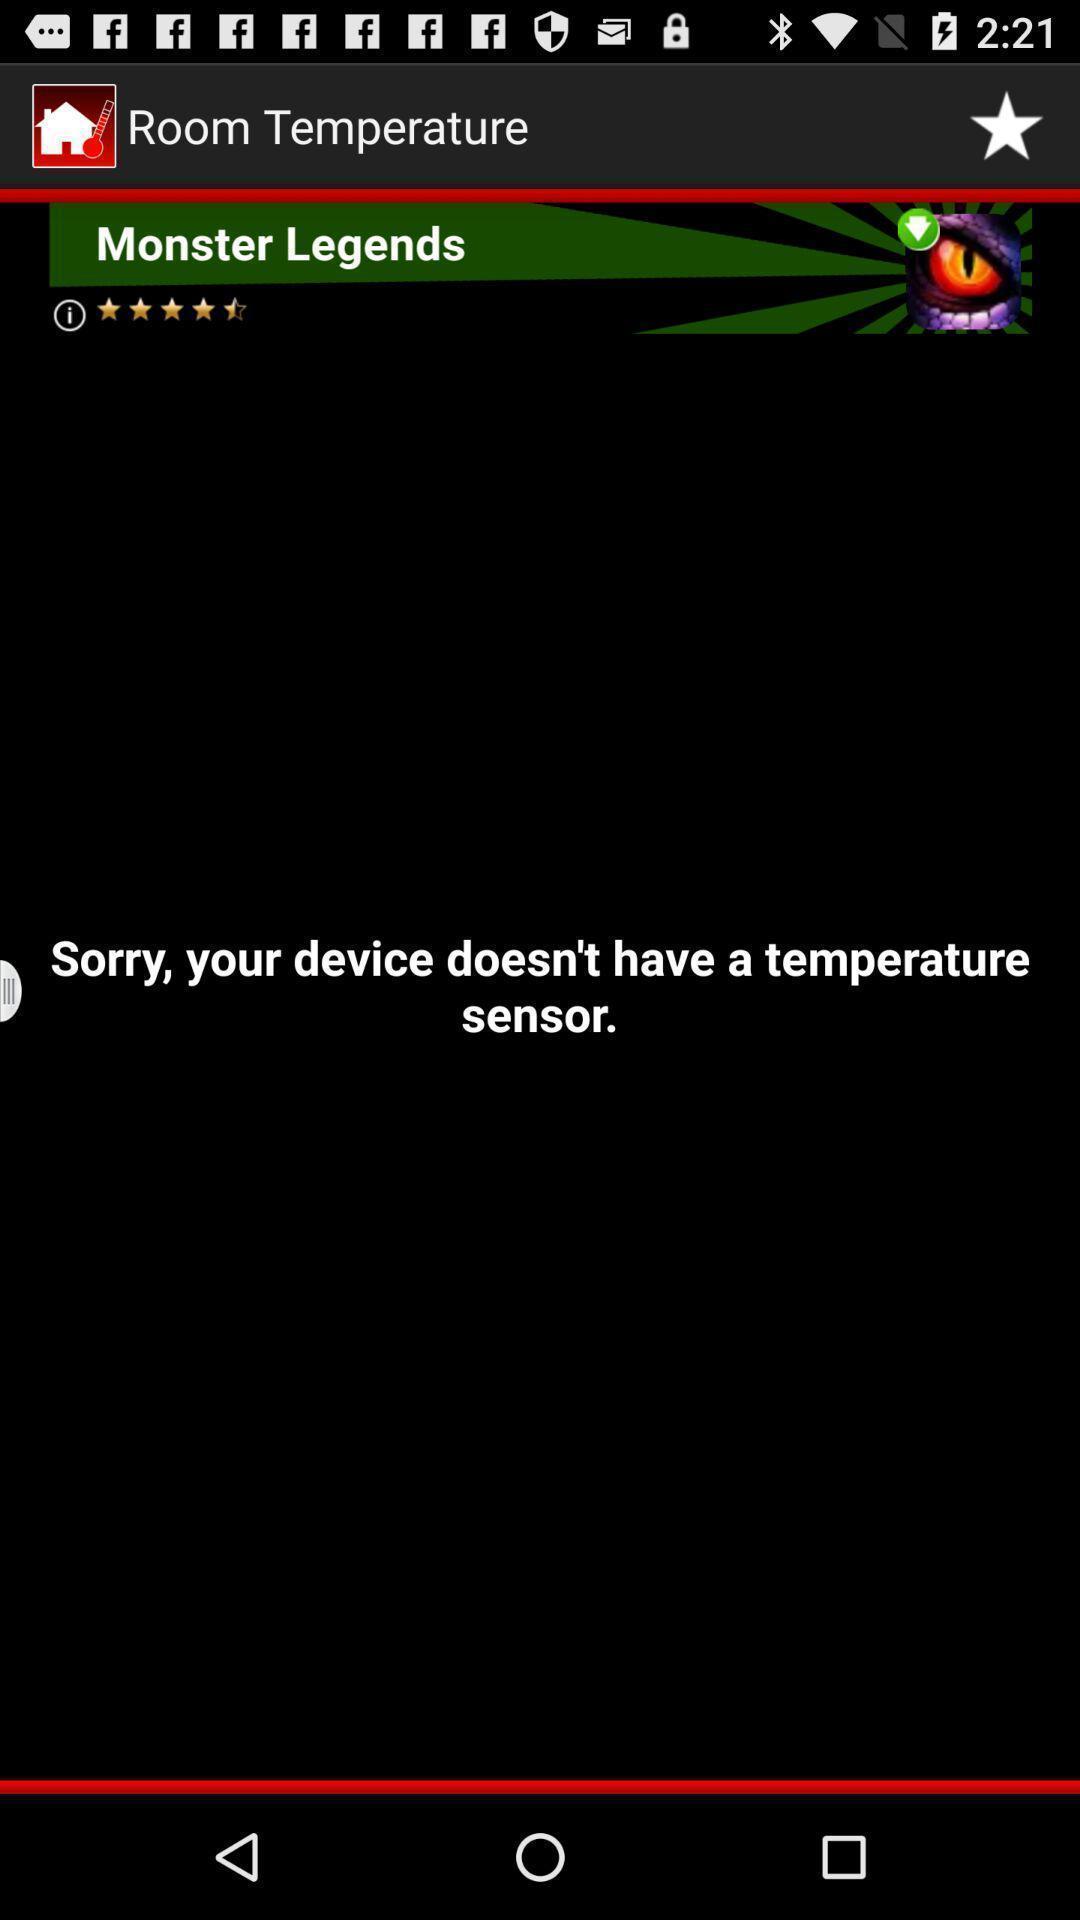Please provide a description for this image. Page shows about room temperature. 